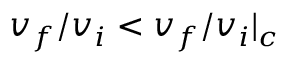Convert formula to latex. <formula><loc_0><loc_0><loc_500><loc_500>v _ { f } / v _ { i } < v _ { f } / v _ { i } | _ { c }</formula> 